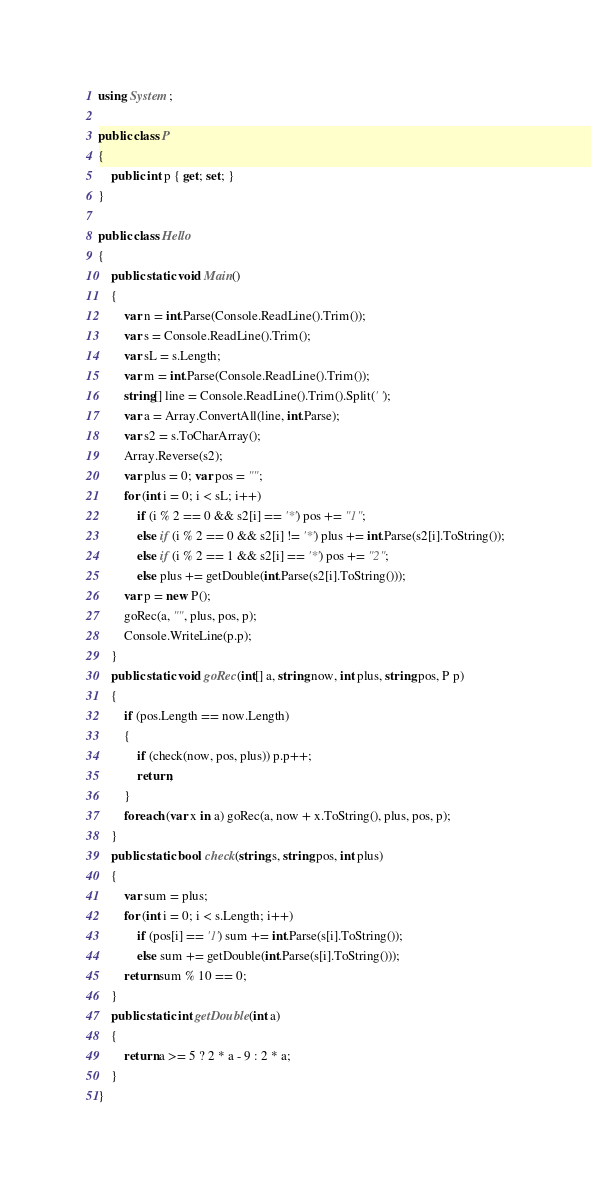<code> <loc_0><loc_0><loc_500><loc_500><_C#_>using System;

public class P
{
    public int p { get; set; }
}

public class Hello
{
    public static void Main()
    {
        var n = int.Parse(Console.ReadLine().Trim());
        var s = Console.ReadLine().Trim();
        var sL = s.Length;
        var m = int.Parse(Console.ReadLine().Trim());
        string[] line = Console.ReadLine().Trim().Split(' ');
        var a = Array.ConvertAll(line, int.Parse);
        var s2 = s.ToCharArray();
        Array.Reverse(s2);
        var plus = 0; var pos = "";
        for (int i = 0; i < sL; i++)
            if (i % 2 == 0 && s2[i] == '*') pos += "1";
            else if (i % 2 == 0 && s2[i] != '*') plus += int.Parse(s2[i].ToString());
            else if (i % 2 == 1 && s2[i] == '*') pos += "2";
            else plus += getDouble(int.Parse(s2[i].ToString()));
        var p = new P();
        goRec(a, "", plus, pos, p);
        Console.WriteLine(p.p);
    }
    public static void goRec(int[] a, string now, int plus, string pos, P p)
    {
        if (pos.Length == now.Length)
        {
            if (check(now, pos, plus)) p.p++;
            return;
        }
        foreach (var x in a) goRec(a, now + x.ToString(), plus, pos, p);
    }
    public static bool check(string s, string pos, int plus)
    {
        var sum = plus;
        for (int i = 0; i < s.Length; i++)
            if (pos[i] == '1') sum += int.Parse(s[i].ToString());
            else sum += getDouble(int.Parse(s[i].ToString()));
        return sum % 10 == 0;
    }
    public static int getDouble(int a)
    {
        return a >= 5 ? 2 * a - 9 : 2 * a;
    }
}

</code> 